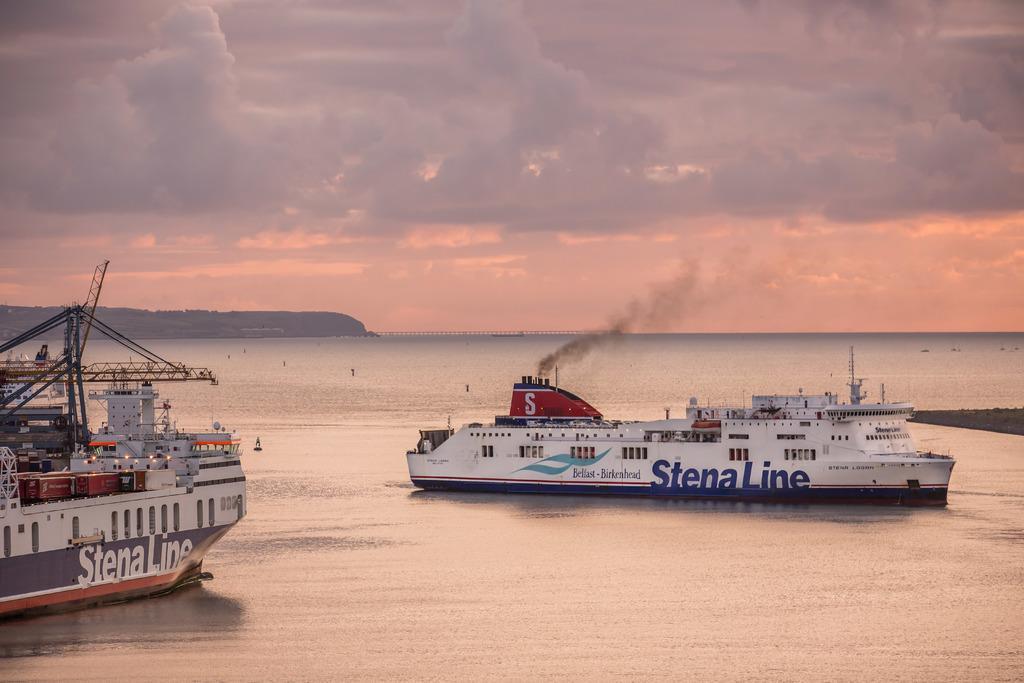Please provide a concise description of this image. There are two large ships sailing on the sea, one of the ship is emitting smoke through the pipes and the weather is very pleasant. 